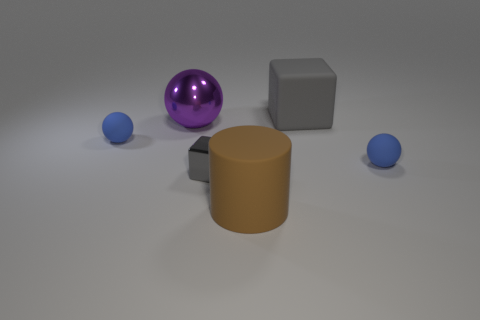What is the lighting source in this image? The lighting in the image seems to be coming from above, given the shadows cast directly underneath the objects, suggesting an overhead artificial light source. 